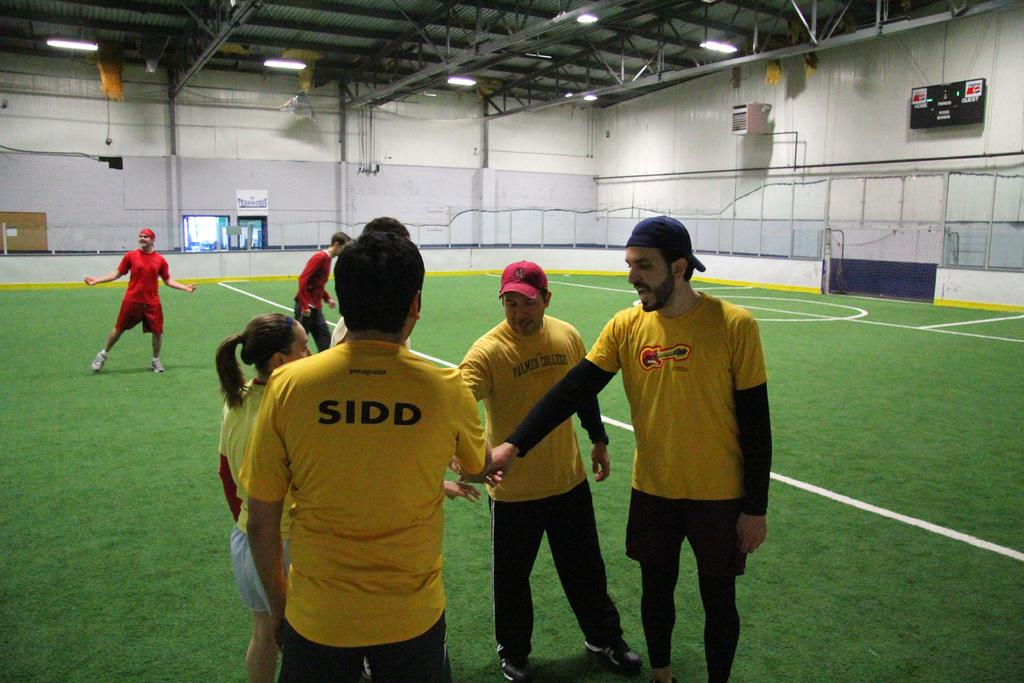Provide a one-sentence caption for the provided image. A team of sports players coming together to cheer the other team. 